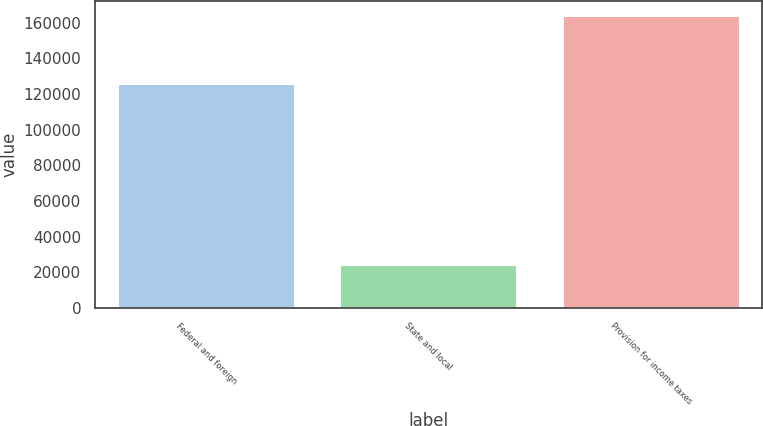Convert chart to OTSL. <chart><loc_0><loc_0><loc_500><loc_500><bar_chart><fcel>Federal and foreign<fcel>State and local<fcel>Provision for income taxes<nl><fcel>126075<fcel>24651<fcel>164098<nl></chart> 